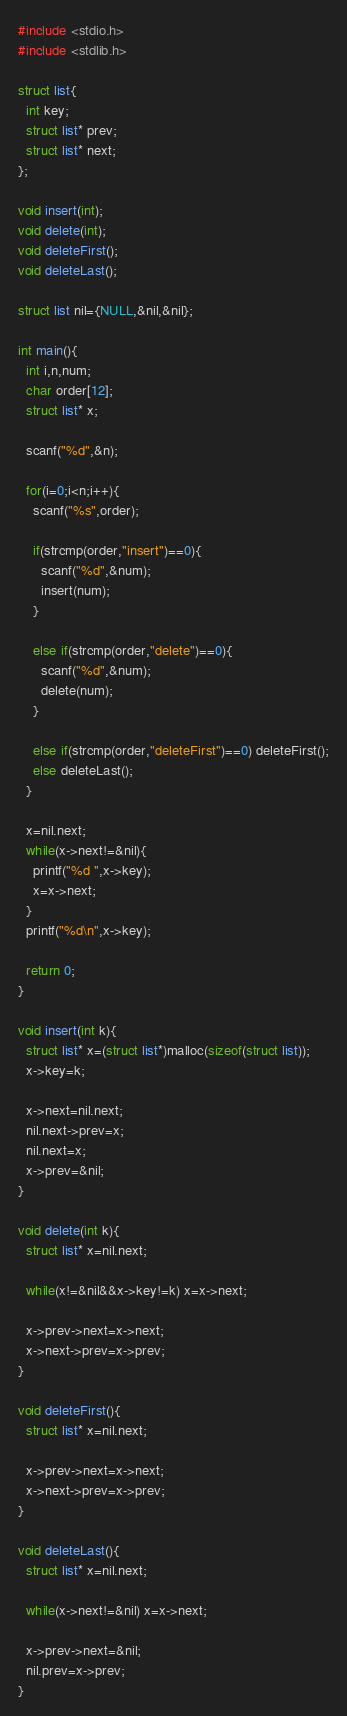Convert code to text. <code><loc_0><loc_0><loc_500><loc_500><_C_>#include <stdio.h>
#include <stdlib.h>

struct list{
  int key;
  struct list* prev;
  struct list* next;
};

void insert(int);
void delete(int);
void deleteFirst();
void deleteLast();

struct list nil={NULL,&nil,&nil};

int main(){
  int i,n,num;
  char order[12];
  struct list* x;

  scanf("%d",&n);

  for(i=0;i<n;i++){
    scanf("%s",order);

    if(strcmp(order,"insert")==0){
      scanf("%d",&num);
      insert(num);
    }

    else if(strcmp(order,"delete")==0){
      scanf("%d",&num);
      delete(num);
    }

    else if(strcmp(order,"deleteFirst")==0) deleteFirst();
    else deleteLast();
  }

  x=nil.next;
  while(x->next!=&nil){
    printf("%d ",x->key);
    x=x->next;
  }
  printf("%d\n",x->key);

  return 0;
}

void insert(int k){
  struct list* x=(struct list*)malloc(sizeof(struct list));
  x->key=k;

  x->next=nil.next;
  nil.next->prev=x;
  nil.next=x;
  x->prev=&nil;
}

void delete(int k){
  struct list* x=nil.next;

  while(x!=&nil&&x->key!=k) x=x->next;

  x->prev->next=x->next;
  x->next->prev=x->prev;
}

void deleteFirst(){
  struct list* x=nil.next;
  
  x->prev->next=x->next;
  x->next->prev=x->prev;
}

void deleteLast(){
  struct list* x=nil.next;

  while(x->next!=&nil) x=x->next;

  x->prev->next=&nil;
  nil.prev=x->prev;
}</code> 